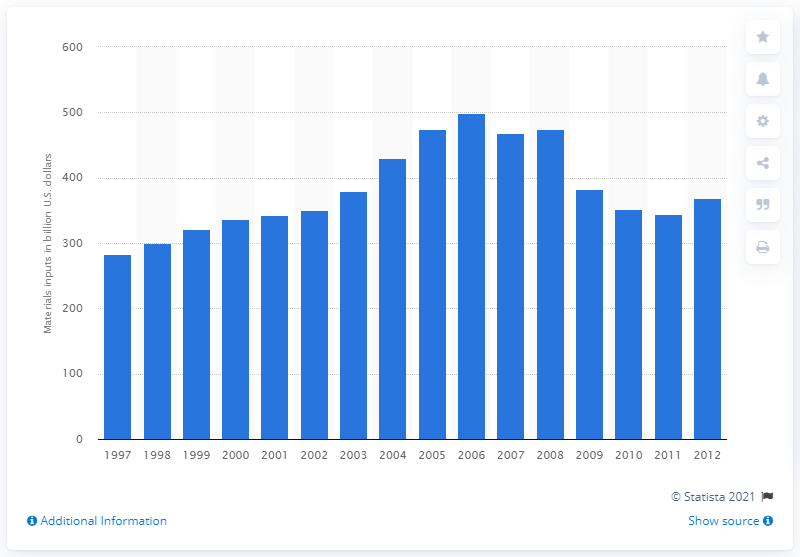Outline some significant characteristics in this image. In 2000, the cost of materials inputs for the US construction industry was approximately $336.99. 